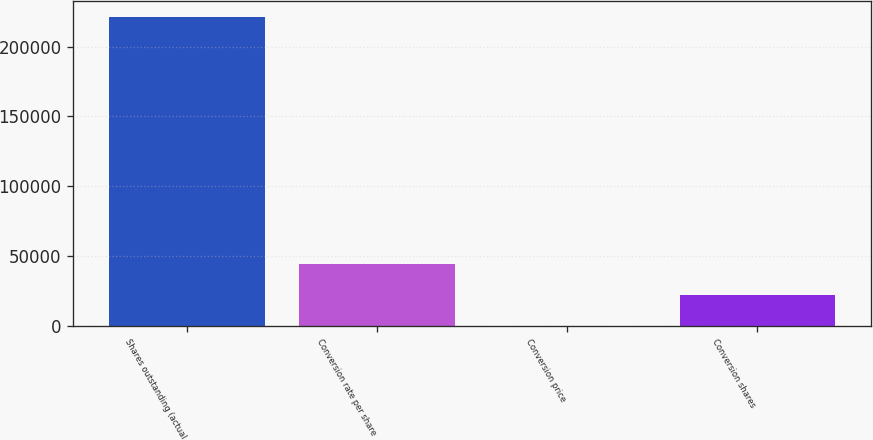<chart> <loc_0><loc_0><loc_500><loc_500><bar_chart><fcel>Shares outstanding (actual<fcel>Conversion rate per share<fcel>Conversion price<fcel>Conversion shares<nl><fcel>221474<fcel>44305.3<fcel>13.12<fcel>22159.2<nl></chart> 